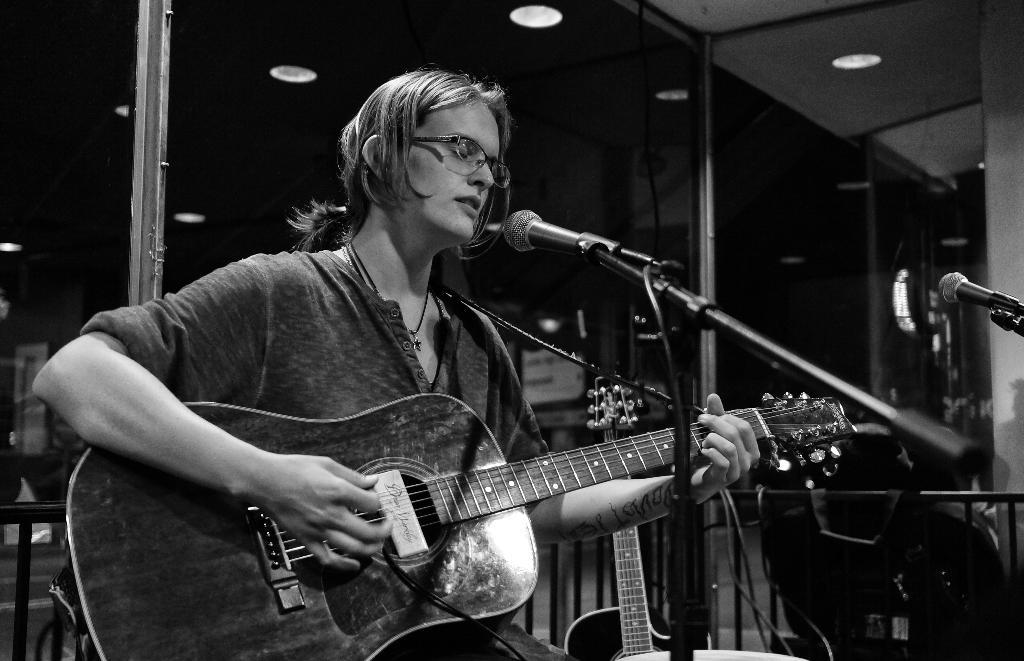Who is the main subject in the image? There is a woman in the image. What is the woman doing in the image? The woman is performing in the image. What instrument is the woman playing? The woman is playing a guitar in the image. What device is present for amplifying her voice? There is a microphone in the image. Can you see any feathers floating around the woman while she is performing? No, there are no feathers present in the image. 